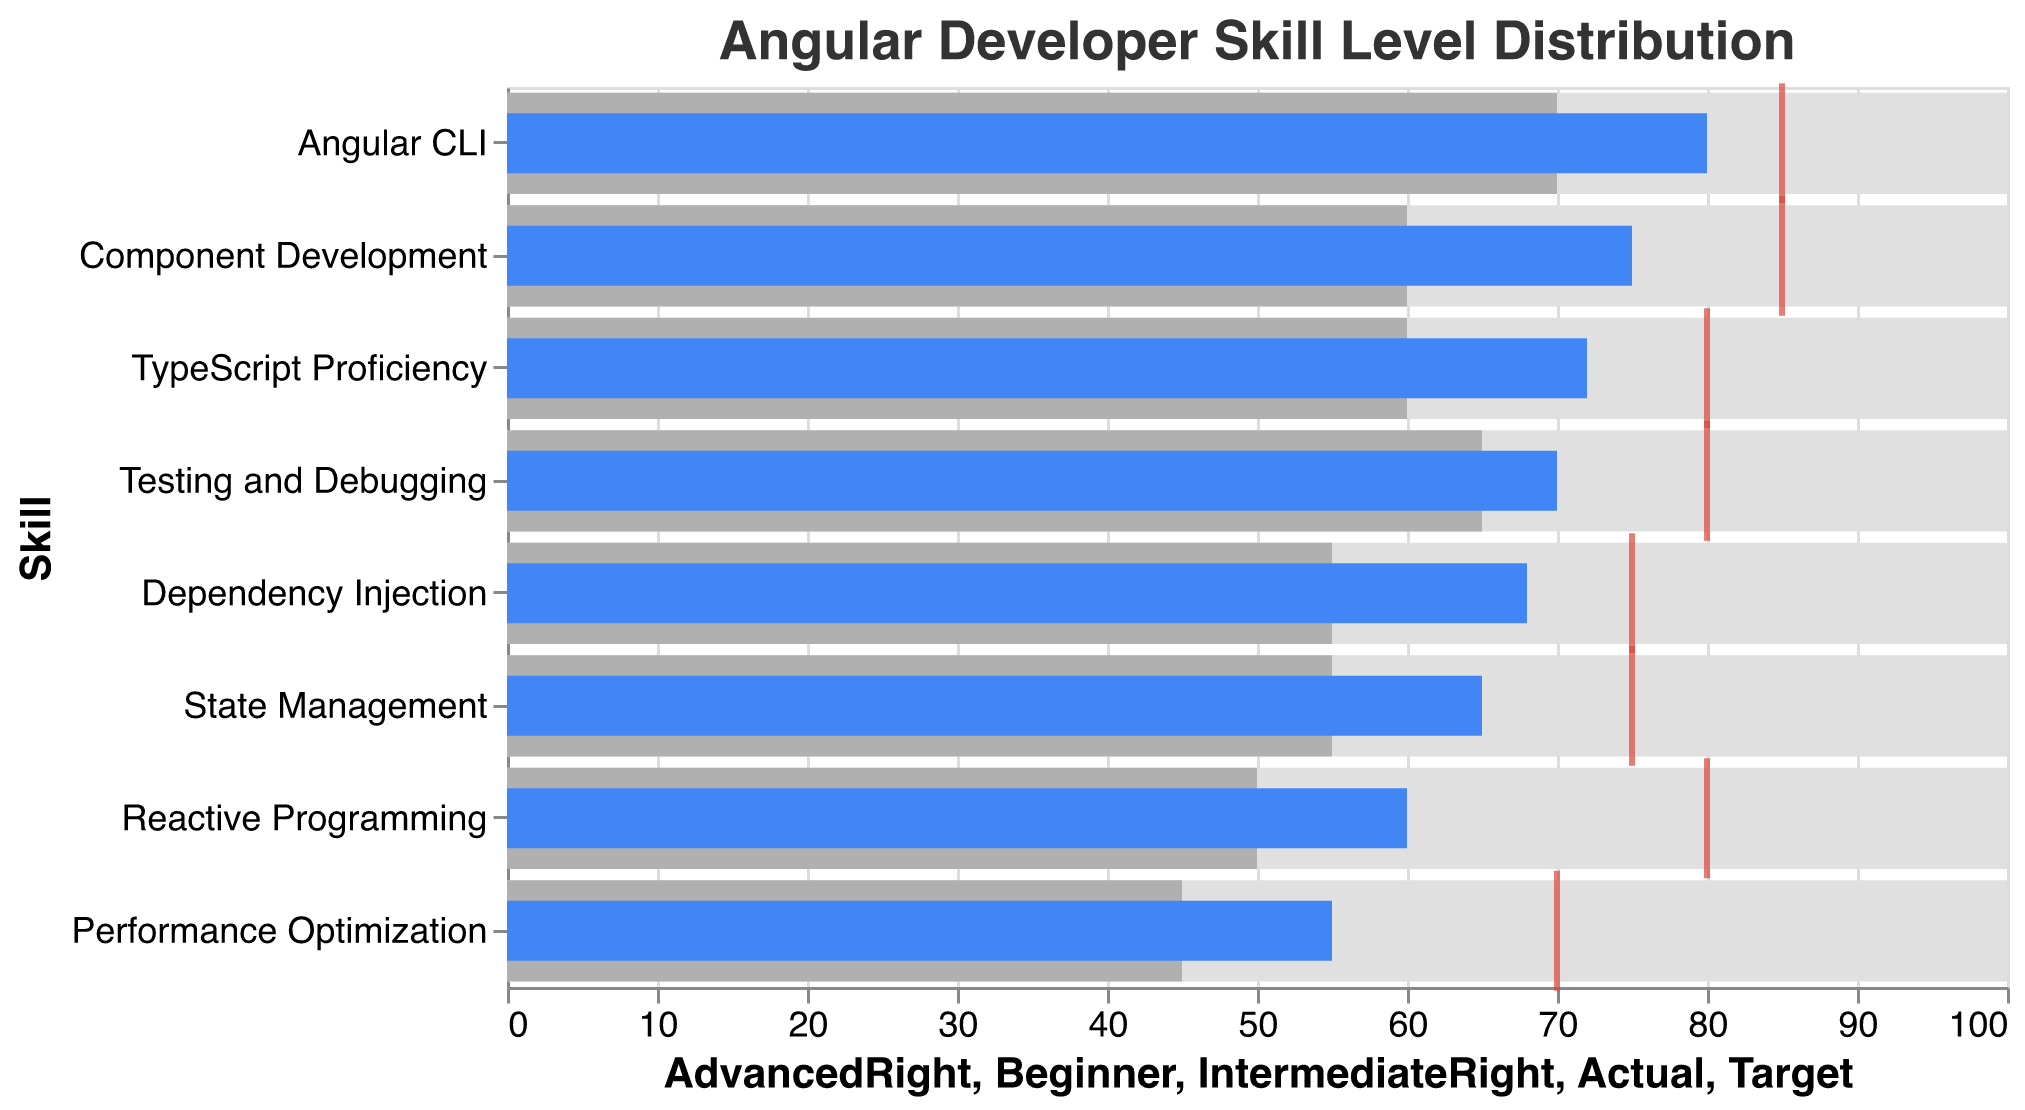Which skill category has the highest actual proficiency level? By looking at the blue bars, the longest one represents the highest actual proficiency. Here, it corresponds to Angular CLI with an actual proficiency level of 80.
Answer: Angular CLI What is the title of the chart? The title of the chart is located at the top of the plot and reads "Angular Developer Skill Level Distribution".
Answer: Angular Developer Skill Level Distribution How many skill categories have an actual proficiency above 70? By examining the blue bars, Angular CLI (80), Component Development (75), Testing and Debugging (70), and TypeScript Proficiency (72) all have actual proficiency levels above 70. Thus, there are four such categories.
Answer: 4 What is the difference between the actual and target proficiency levels for Reactive Programming? Compare the actual proficiency level of 60 with the target proficiency level of 80. The difference is 80 - 60 = 20.
Answer: 20 Which skill category has the largest gap between actual and target proficiency levels? Calculate the difference for each category and determine which is the largest. Performance Optimization (target 70, actual 55) has the largest gap, 70 - 55 = 15.
Answer: Performance Optimization What is the color used to denote the target proficiency level in the chart? The target proficiency levels are marked with a red tick, the color used is red.
Answer: Red Which skill has the smallest gap between actual and target proficiency levels? Calculate the gap for each skill and find the smallest one. Angular CLI has a target of 85 and an actual of 80, giving a gap of 5, which is the smallest.
Answer: Angular CLI What is the range considered as Intermediate proficiency? Intermediate proficiency levels range from the starting point of 0 to the end point denoted by a lighter grey bar. This range is from 0 to the value in the Intermediate column, which is usually lower than Advanced.
Answer: 0 to Intermediate value How does the actual proficiency in State Management compare to Performance Optimization? Compare the lengths of the blue bars. State Management has an actual proficiency level of 65, whereas Performance Optimization has 55. Thus, State Management is higher.
Answer: State Management is higher What is the target proficiency for TypeScript Proficiency? Refer to the red tick for TypeScript Proficiency, which indicates the target proficiency level. It is marked at 80.
Answer: 80 